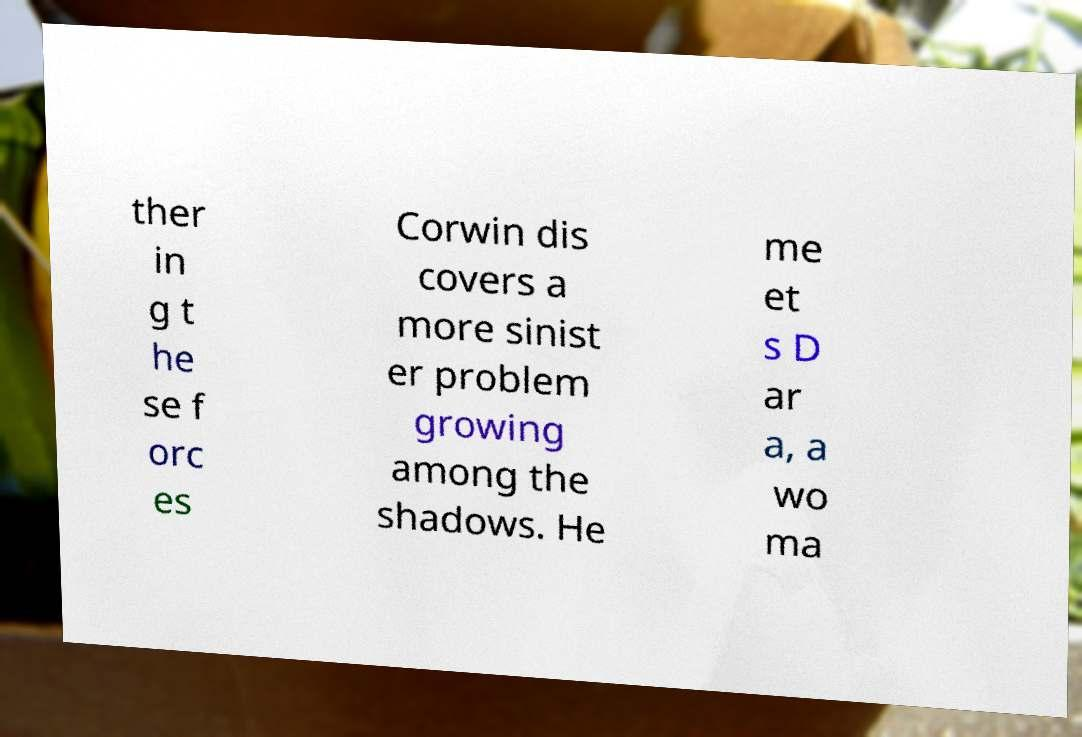I need the written content from this picture converted into text. Can you do that? ther in g t he se f orc es Corwin dis covers a more sinist er problem growing among the shadows. He me et s D ar a, a wo ma 